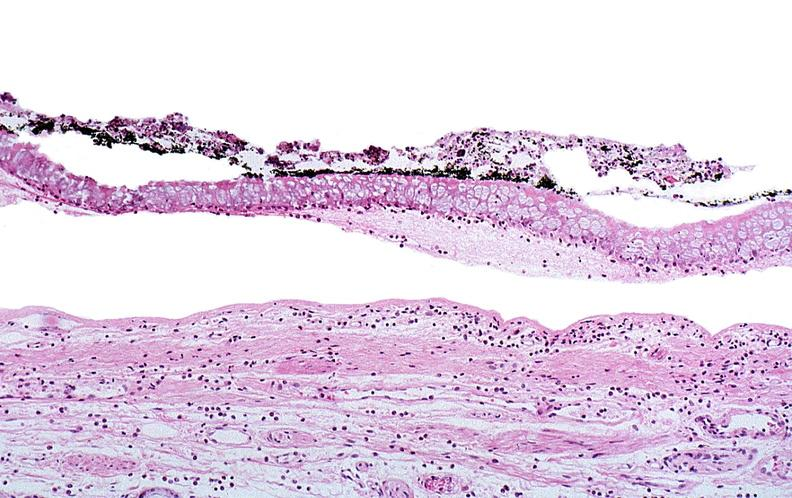does this image show thermal burned skin?
Answer the question using a single word or phrase. Yes 